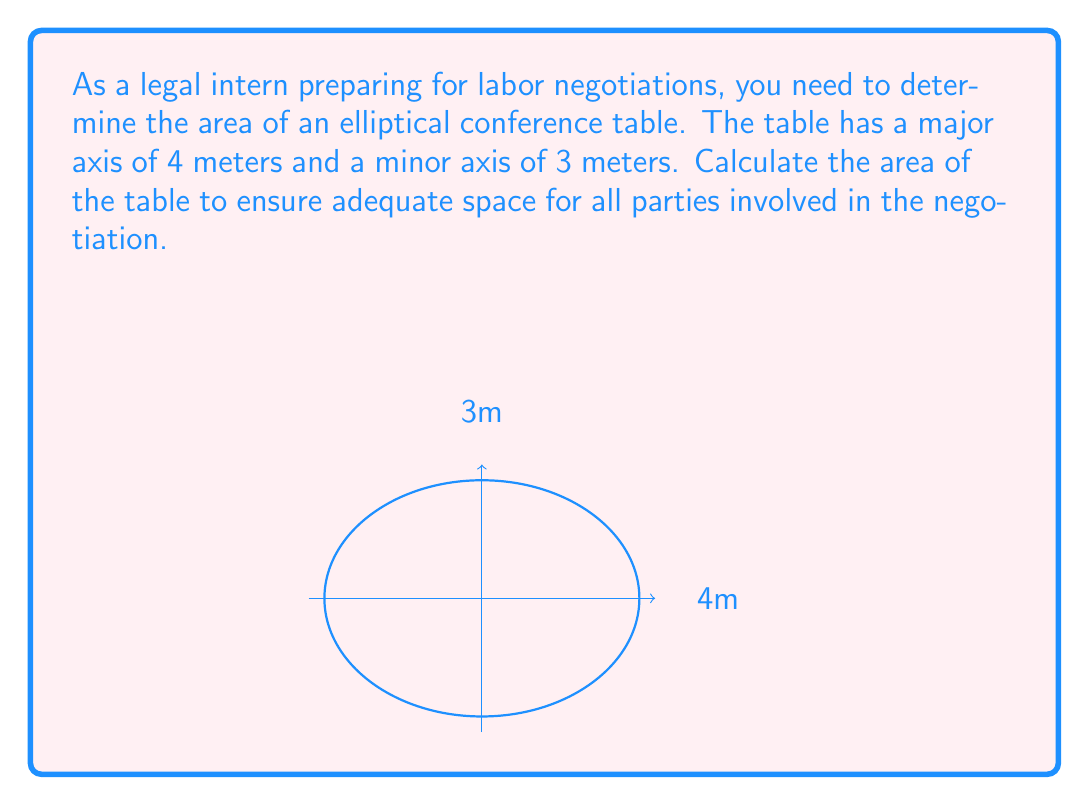What is the answer to this math problem? To calculate the area of an elliptical table, we use the formula:

$$ A = \pi ab $$

Where:
$a$ is half the length of the major axis
$b$ is half the length of the minor axis

Given:
- Major axis = 4 meters
- Minor axis = 3 meters

Step 1: Determine $a$ and $b$
$a = \frac{4}{2} = 2$ meters
$b = \frac{3}{2} = 1.5$ meters

Step 2: Apply the formula
$$ A = \pi ab $$
$$ A = \pi (2)(1.5) $$
$$ A = 3\pi $$

Step 3: Calculate the final result
$$ A = 3\pi \approx 9.42 \text{ m}^2 $$

Therefore, the area of the elliptical conference table is approximately 9.42 square meters.
Answer: $3\pi \approx 9.42 \text{ m}^2$ 